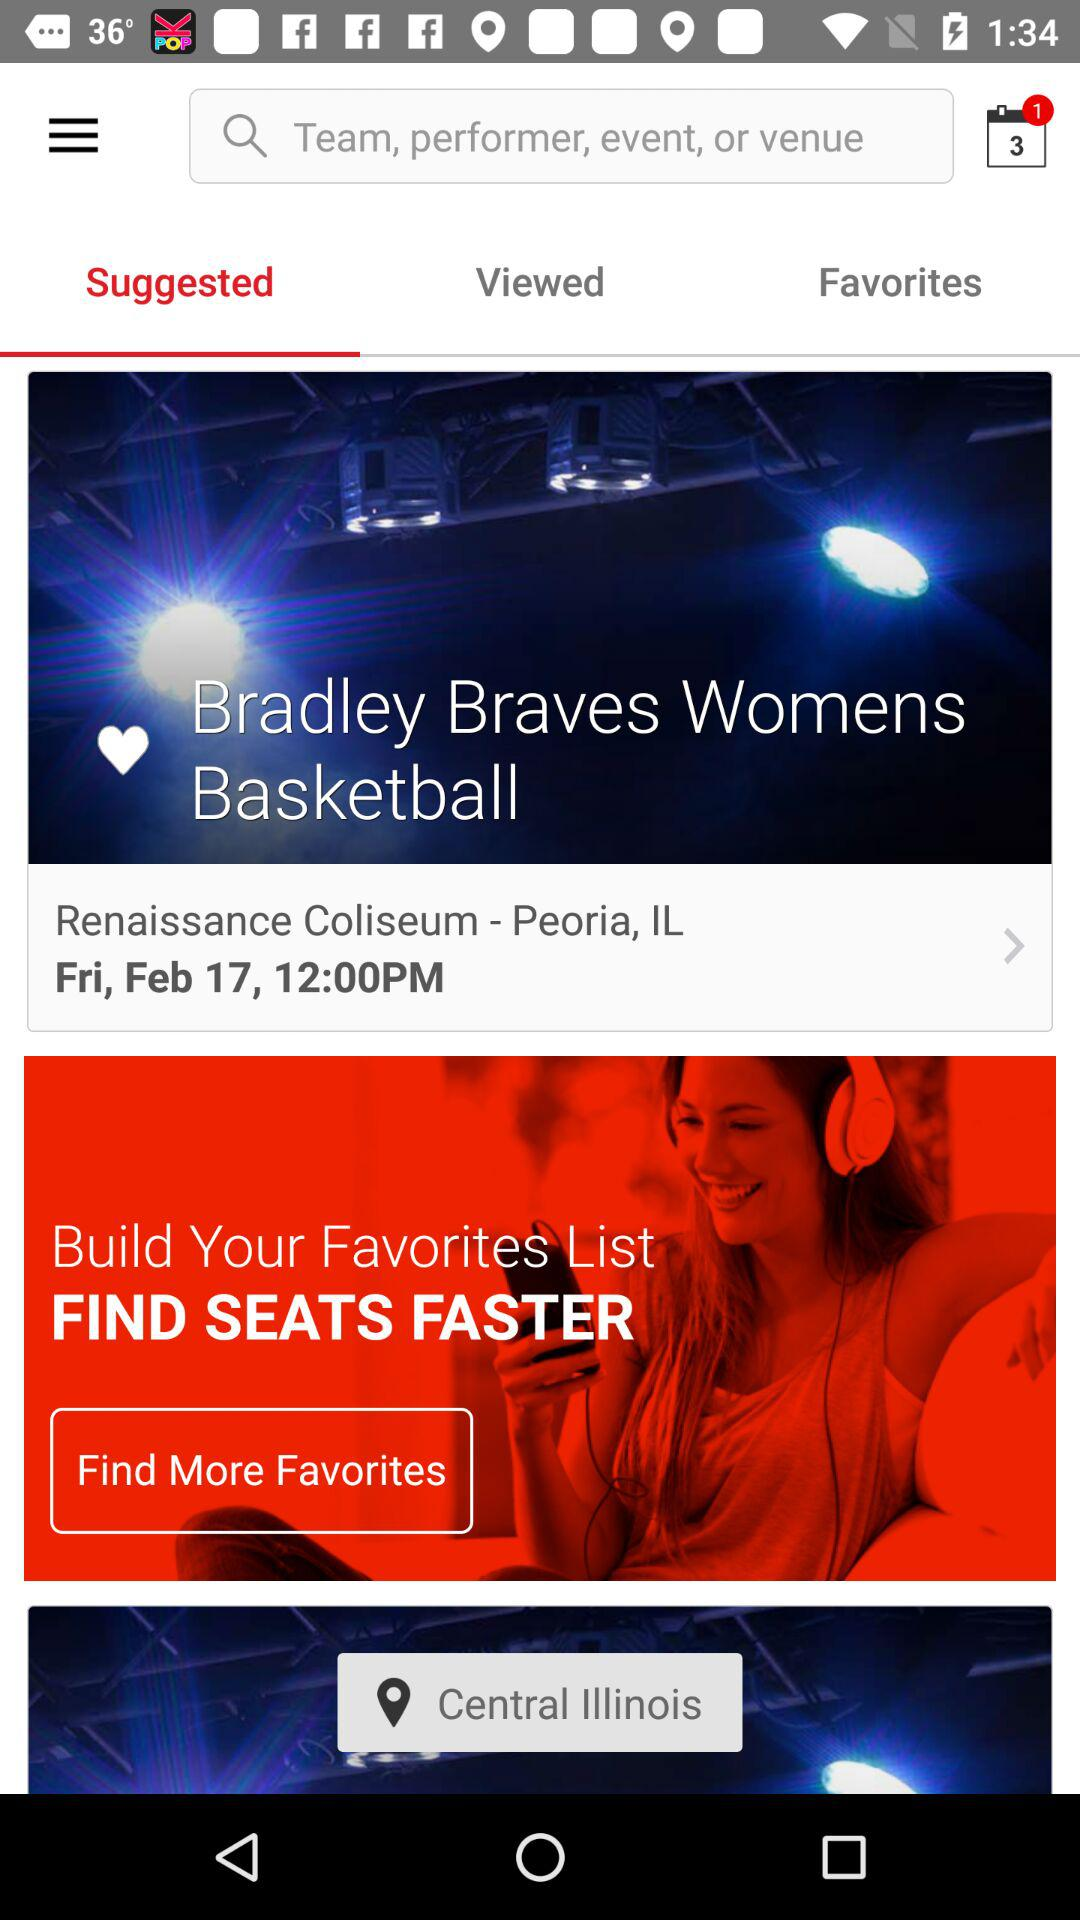How many alert notifications are there on the calendar? There is 1 alert notification on the calendar. 